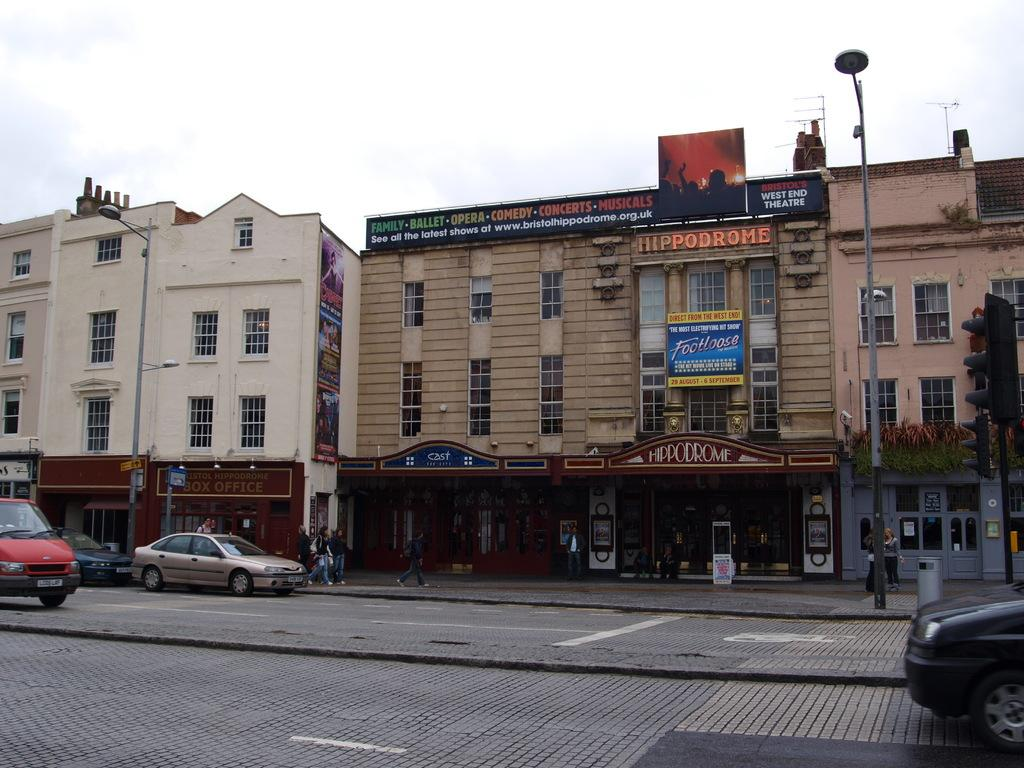What can be seen on the road in the image? There are vehicles on the road in the image. What structures can be seen in the background? There are buildings visible in the image. What are the people near the road doing? There are people walking near the road in the image. Is there a volcano erupting in the background of the image? No, there is no volcano present in the image. Are there any firemen or police officers visible in the image? No, there are no firemen or police officers mentioned or visible in the image. 